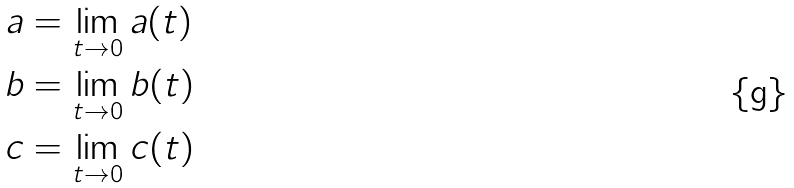Convert formula to latex. <formula><loc_0><loc_0><loc_500><loc_500>a & = \lim _ { t \to 0 } a ( t ) \\ b & = \lim _ { t \to 0 } b ( t ) \\ c & = \lim _ { t \to 0 } c ( t )</formula> 